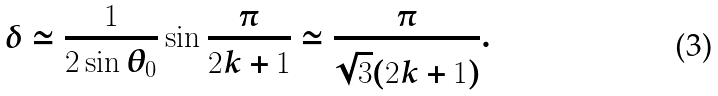Convert formula to latex. <formula><loc_0><loc_0><loc_500><loc_500>\delta \simeq \frac { 1 } { 2 \sin \theta _ { 0 } } \sin \frac { \pi } { 2 k + 1 } \simeq \frac { \pi } { \sqrt { 3 } ( 2 k + 1 ) } .</formula> 